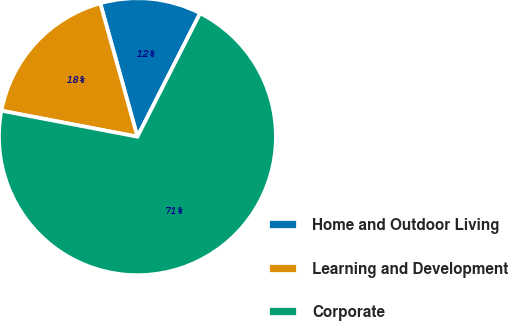Convert chart to OTSL. <chart><loc_0><loc_0><loc_500><loc_500><pie_chart><fcel>Home and Outdoor Living<fcel>Learning and Development<fcel>Corporate<nl><fcel>11.8%<fcel>17.67%<fcel>70.53%<nl></chart> 